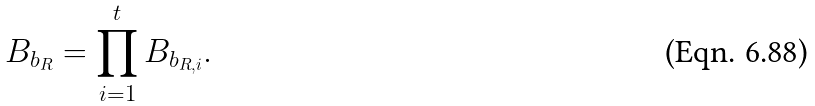Convert formula to latex. <formula><loc_0><loc_0><loc_500><loc_500>B _ { b _ { R } } = \prod _ { i = 1 } ^ { t } B _ { b _ { R , i } } .</formula> 